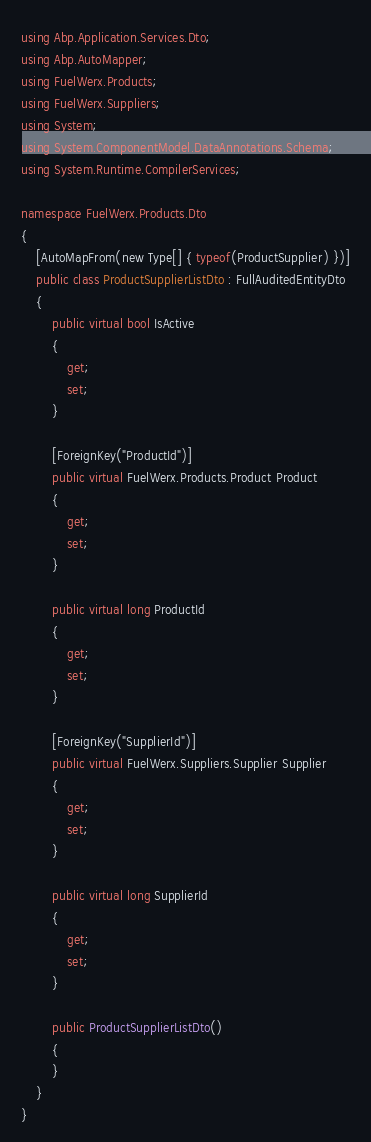Convert code to text. <code><loc_0><loc_0><loc_500><loc_500><_C#_>using Abp.Application.Services.Dto;
using Abp.AutoMapper;
using FuelWerx.Products;
using FuelWerx.Suppliers;
using System;
using System.ComponentModel.DataAnnotations.Schema;
using System.Runtime.CompilerServices;

namespace FuelWerx.Products.Dto
{
	[AutoMapFrom(new Type[] { typeof(ProductSupplier) })]
	public class ProductSupplierListDto : FullAuditedEntityDto
	{
		public virtual bool IsActive
		{
			get;
			set;
		}

		[ForeignKey("ProductId")]
		public virtual FuelWerx.Products.Product Product
		{
			get;
			set;
		}

		public virtual long ProductId
		{
			get;
			set;
		}

		[ForeignKey("SupplierId")]
		public virtual FuelWerx.Suppliers.Supplier Supplier
		{
			get;
			set;
		}

		public virtual long SupplierId
		{
			get;
			set;
		}

		public ProductSupplierListDto()
		{
		}
	}
}</code> 